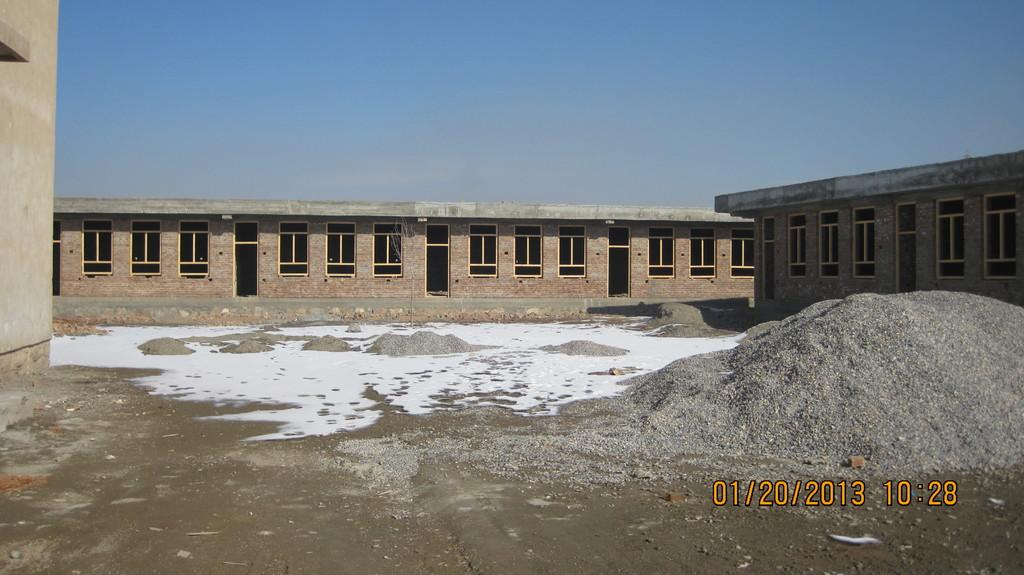What type of structures are present in the image? There are houses in the image. What features can be seen on the houses? The houses have windows and doors. What natural elements are visible in the image? There are rocks visible in the image. How many hands are holding the houses in the image? There are no hands present in the image; the houses are standing on their own. 